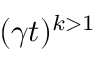Convert formula to latex. <formula><loc_0><loc_0><loc_500><loc_500>( \gamma t ) ^ { k > 1 }</formula> 